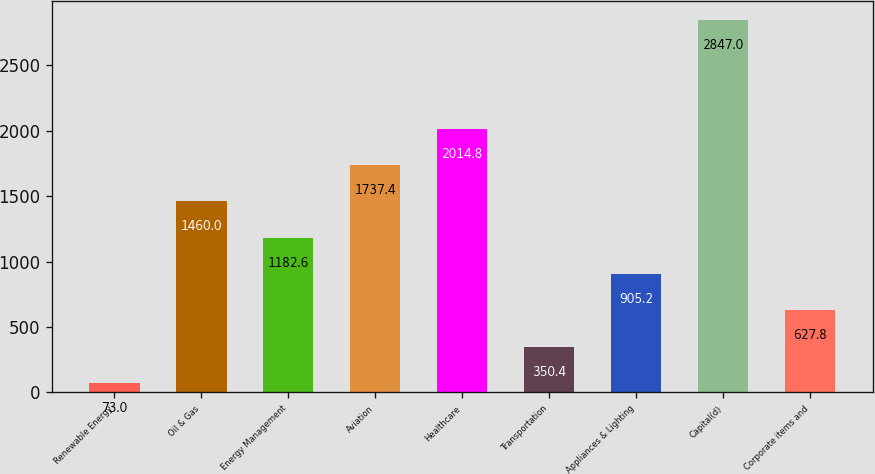Convert chart. <chart><loc_0><loc_0><loc_500><loc_500><bar_chart><fcel>Renewable Energy<fcel>Oil & Gas<fcel>Energy Management<fcel>Aviation<fcel>Healthcare<fcel>Transportation<fcel>Appliances & Lighting<fcel>Capital(d)<fcel>Corporate items and<nl><fcel>73<fcel>1460<fcel>1182.6<fcel>1737.4<fcel>2014.8<fcel>350.4<fcel>905.2<fcel>2847<fcel>627.8<nl></chart> 